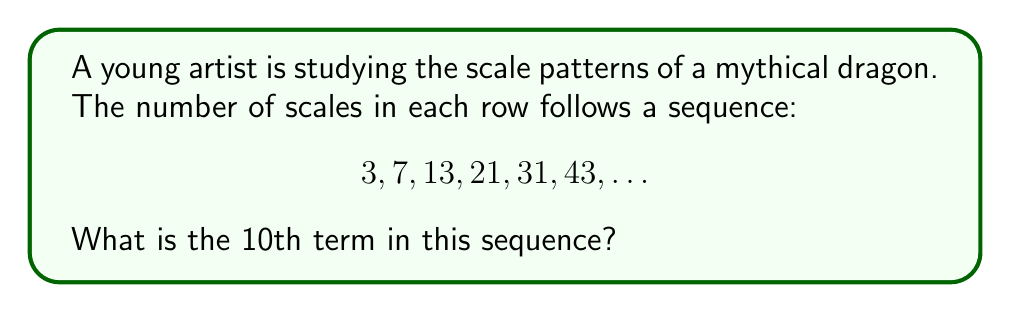Can you answer this question? Let's approach this step-by-step:

1) First, let's look at the differences between consecutive terms:
   3 to 7: difference of 4
   7 to 13: difference of 6
   13 to 21: difference of 8
   21 to 31: difference of 10
   31 to 43: difference of 12

2) We can see that the differences are increasing by 2 each time:
   4, 6, 8, 10, 12, ...

3) This suggests that the sequence is a quadratic sequence.

4) The general form of a quadratic sequence is:
   $$a_n = an^2 + bn + c$$
   where $n$ is the position in the sequence (starting from 1), and $a$, $b$, and $c$ are constants we need to find.

5) We can use the first three terms to set up a system of equations:
   $$3 = a(1)^2 + b(1) + c$$
   $$7 = a(2)^2 + b(2) + c$$
   $$13 = a(3)^2 + b(3) + c$$

6) Solving this system (which is a bit complex to show here), we get:
   $$a = 1, b = 1, c = 1$$

7) So our sequence formula is:
   $$a_n = n^2 + n + 1$$

8) To find the 10th term, we simply plug in $n = 10$:
   $$a_{10} = 10^2 + 10 + 1 = 100 + 10 + 1 = 111$$

Therefore, the 10th term in the sequence is 111.
Answer: 111 